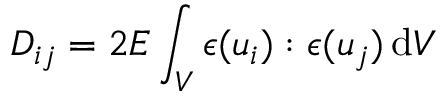Convert formula to latex. <formula><loc_0><loc_0><loc_500><loc_500>D _ { i j } = 2 E \int _ { V } \epsilon ( u _ { i } ) \colon \epsilon ( u _ { j } ) \, d V</formula> 